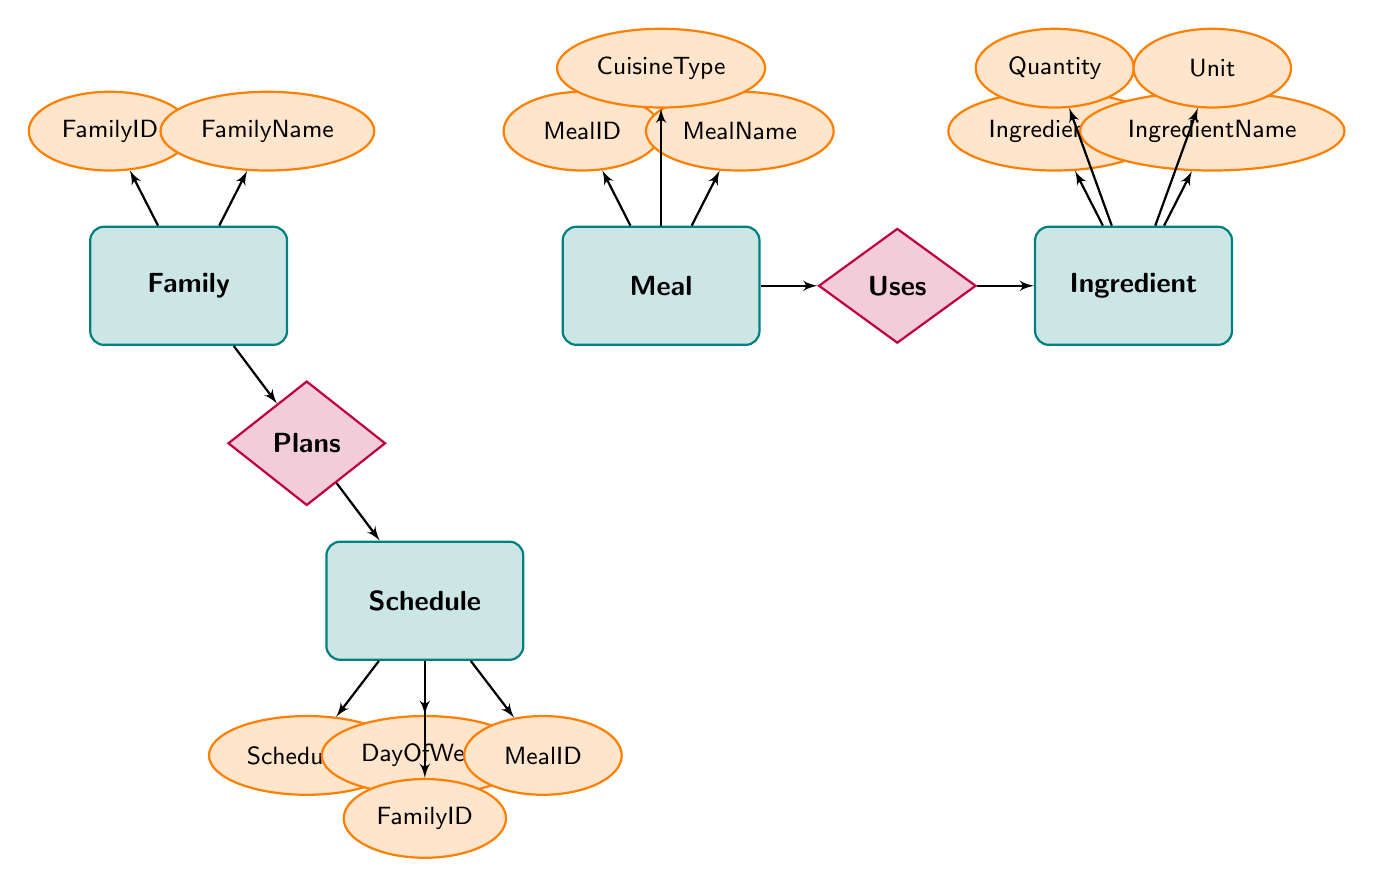What is the main entity in the diagram? The main entity is "Family," which is located at the left side of the diagram. This is evidenced by its central importance in the meal planning process.
Answer: Family How many attributes does the Meal entity have? The Meal entity has three attributes: MealID, MealName, and CuisineType. This can be counted directly from the diagram in the attributes section of the Meal entity.
Answer: Three What relationship connects Meal and Ingredient? The relationship that connects Meal and Ingredient is called "Uses." This is indicated by the labeled diamond between the Meal and Ingredient entities.
Answer: Uses What is the ScheduleID attribute associated with? The ScheduleID attribute is associated with the Schedule entity, providing a unique identifier for each entry in the Schedule. This can be observed in the attributes listed for the Schedule entity.
Answer: Schedule How many relationships are present in the diagram? There are two relationships present in the diagram: "Uses" and "Plans." This can be seen from the connections mapped between the related entities in the diagram.
Answer: Two Which entity is related to the Schedule entity through the "Plans" relationship? The Family entity is related to the Schedule entity through the "Plans" relationship. This is explicitly stated in the diamond representing the Plans relationship and connects Family to Schedule.
Answer: Family What is the attribute related to the DayOfWeek in the Schedule entity? The DayOfWeek attribute in the Schedule entity specifies which day of the week the meal is planned for. It's listed as one of the attributes under the Schedule entity in the diagram.
Answer: DayOfWeek Which entities can use Ingredients? The Meal entity can use Ingredients, as shown by the "Uses" relationship connecting Meal to Ingredient. This indicates that meals are structured based on the ingredients they require.
Answer: Meal What are the possible attributes of the Ingredient entity? The possible attributes of the Ingredient entity are IngredientID, IngredientName, Quantity, and Unit, which are all listed under the Ingredient entity in the diagram.
Answer: IngredientID, IngredientName, Quantity, Unit How does the Family entity relate to the Schedule? The Family entity relates to the Schedule via the "Plans" relationship, indicating that families have specific meal plans for the week that are represented in the Schedule entity.
Answer: Plans 